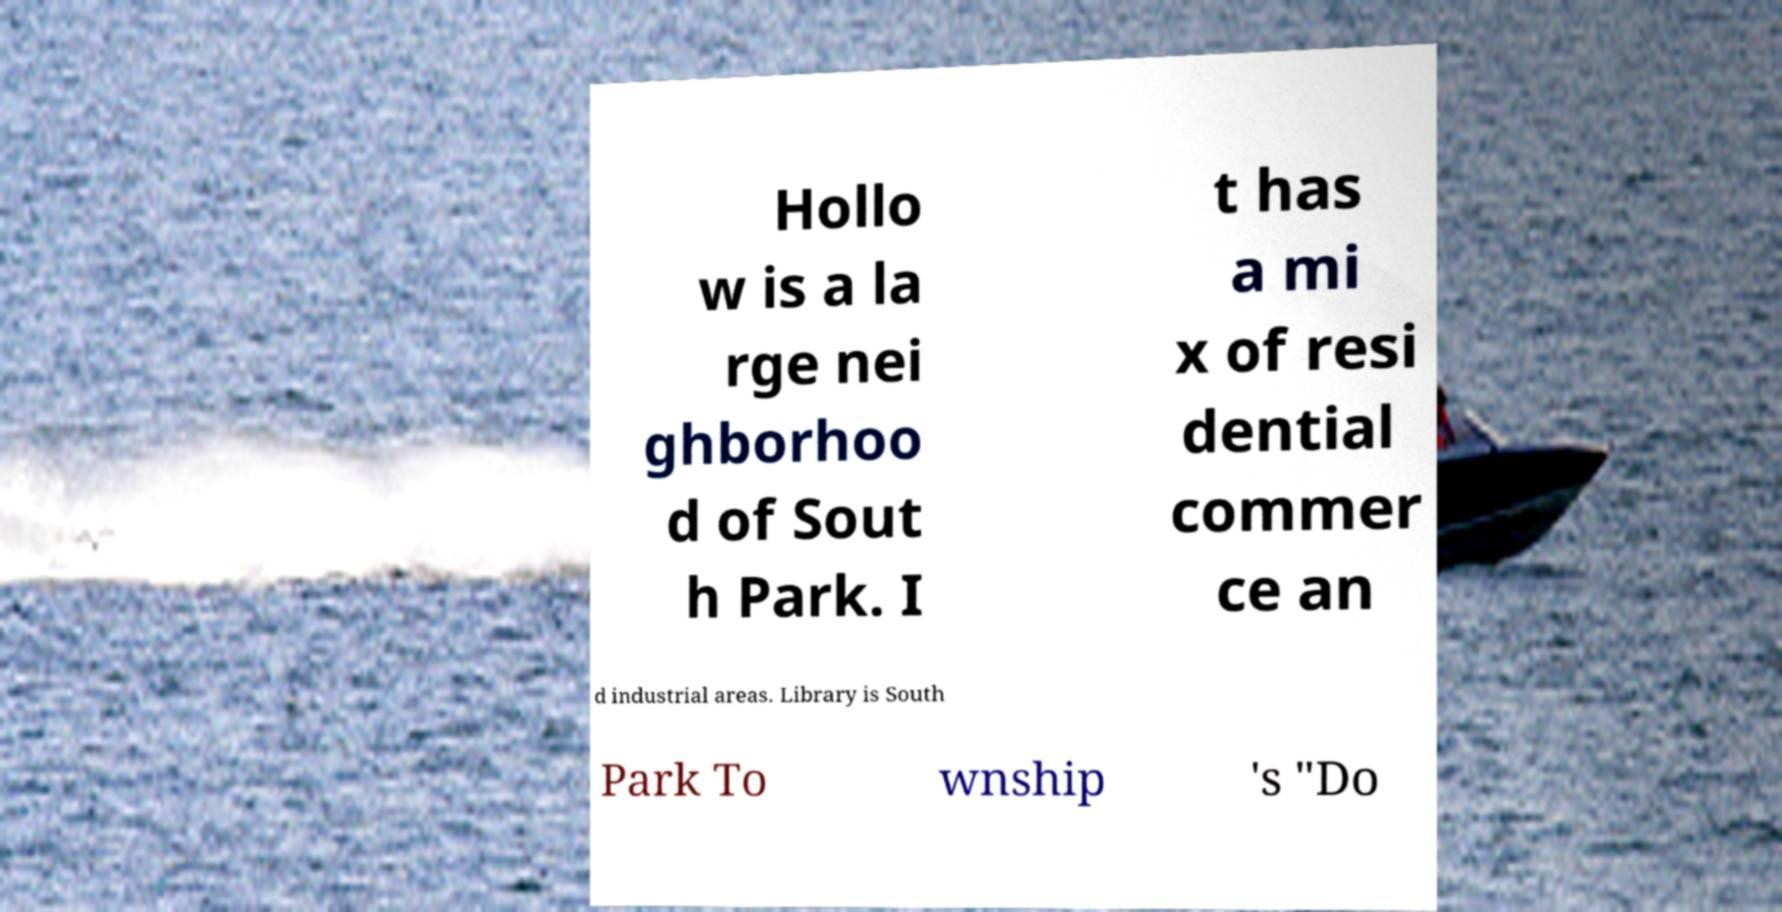Can you accurately transcribe the text from the provided image for me? Hollo w is a la rge nei ghborhoo d of Sout h Park. I t has a mi x of resi dential commer ce an d industrial areas. Library is South Park To wnship 's "Do 